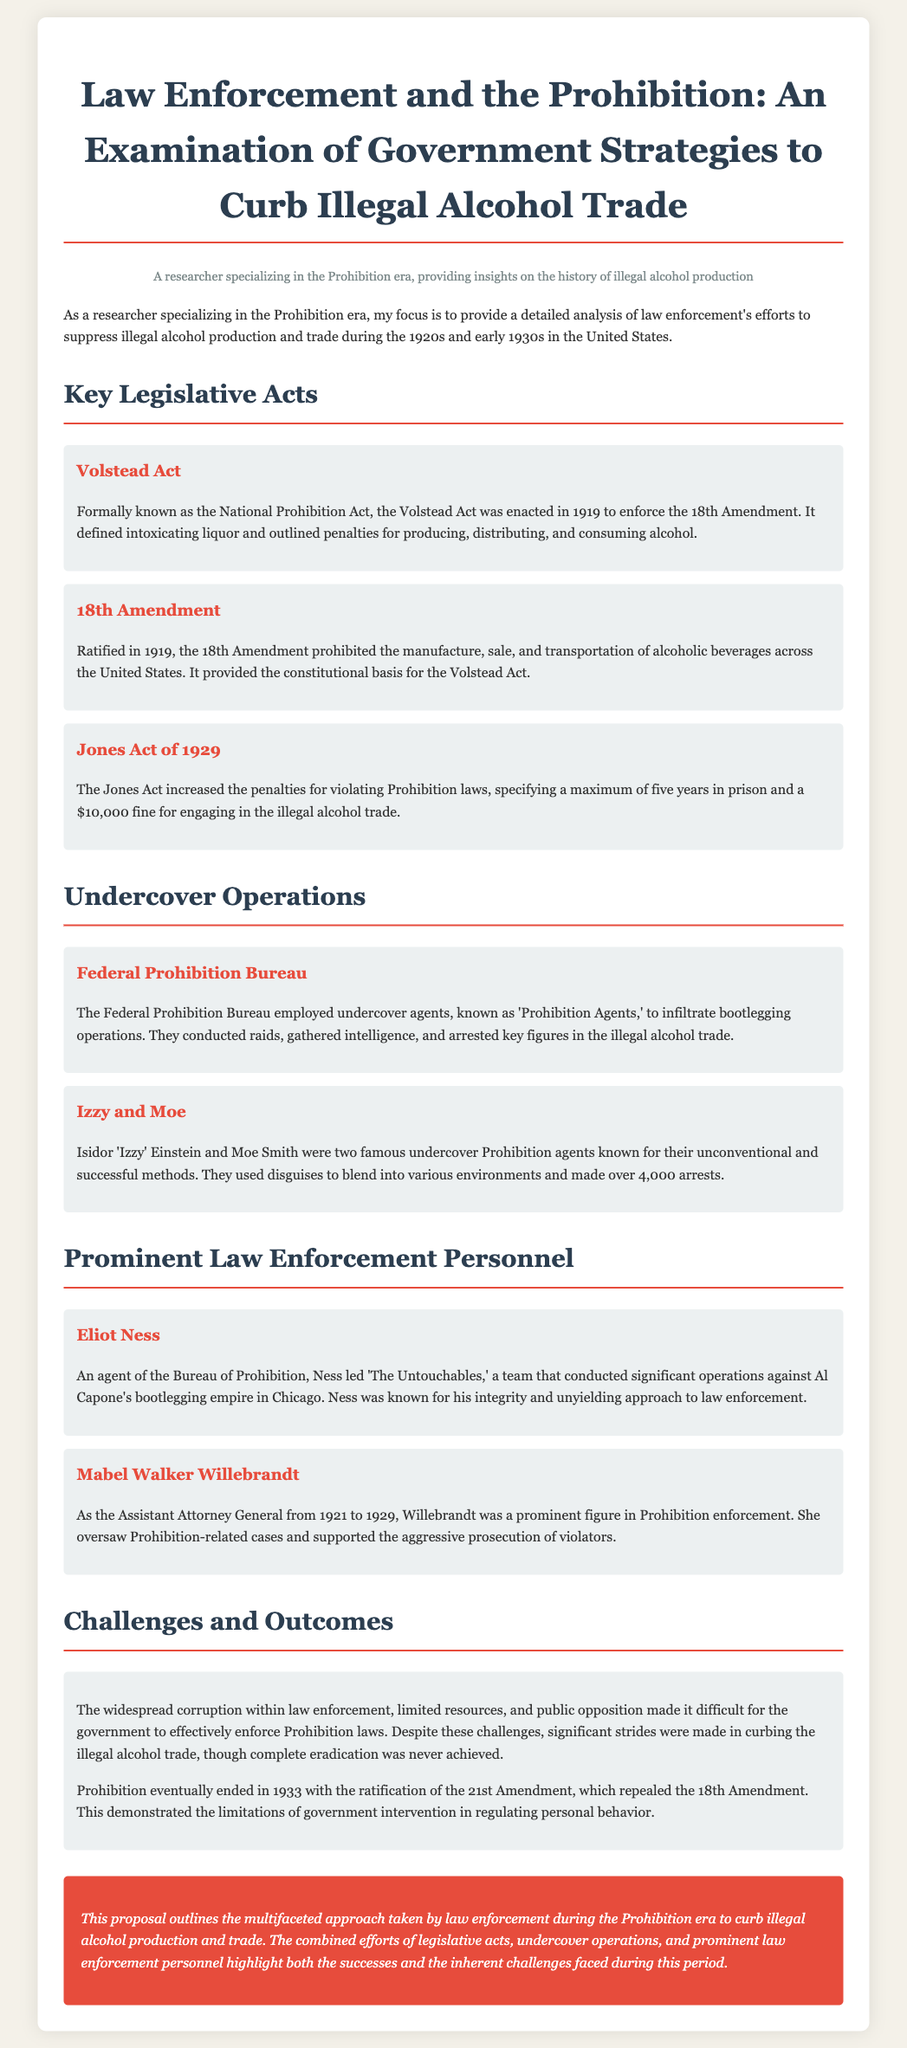what is the title of the proposal? The title of the proposal is stated at the top as "Law Enforcement and the Prohibition: An Examination of Government Strategies to Curb Illegal Alcohol Trade."
Answer: Law Enforcement and the Prohibition: An Examination of Government Strategies to Curb Illegal Alcohol Trade when was the 18th Amendment ratified? The document specifies that the 18th Amendment was ratified in 1919.
Answer: 1919 who were Izzy and Moe? The proposal describes Izzy and Moe as two famous undercover Prohibition agents known for their unconventional and successful methods.
Answer: two famous undercover Prohibition agents what did the Jones Act of 1929 do? The document notes that the Jones Act increased the penalties for violating Prohibition laws.
Answer: increased penalties what is Eliot Ness known for? According to the proposal, Eliot Ness is known for leading 'The Untouchables' against Al Capone's bootlegging empire in Chicago.
Answer: leading 'The Untouchables' what were key challenges faced by law enforcement during Prohibition? The proposal mentions widespread corruption within law enforcement, limited resources, and public opposition.
Answer: corruption, limited resources, public opposition what major outcome resulted from the Prohibition efforts? The document states that Prohibition eventually ended in 1933 with the ratification of the 21st Amendment.
Answer: ratification of the 21st Amendment who was Mabel Walker Willebrandt? The proposal describes Mabel Walker Willebrandt as the Assistant Attorney General from 1921 to 1929.
Answer: Assistant Attorney General from 1921 to 1929 